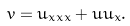Convert formula to latex. <formula><loc_0><loc_0><loc_500><loc_500>v = u _ { x x x } + u u _ { x } .</formula> 